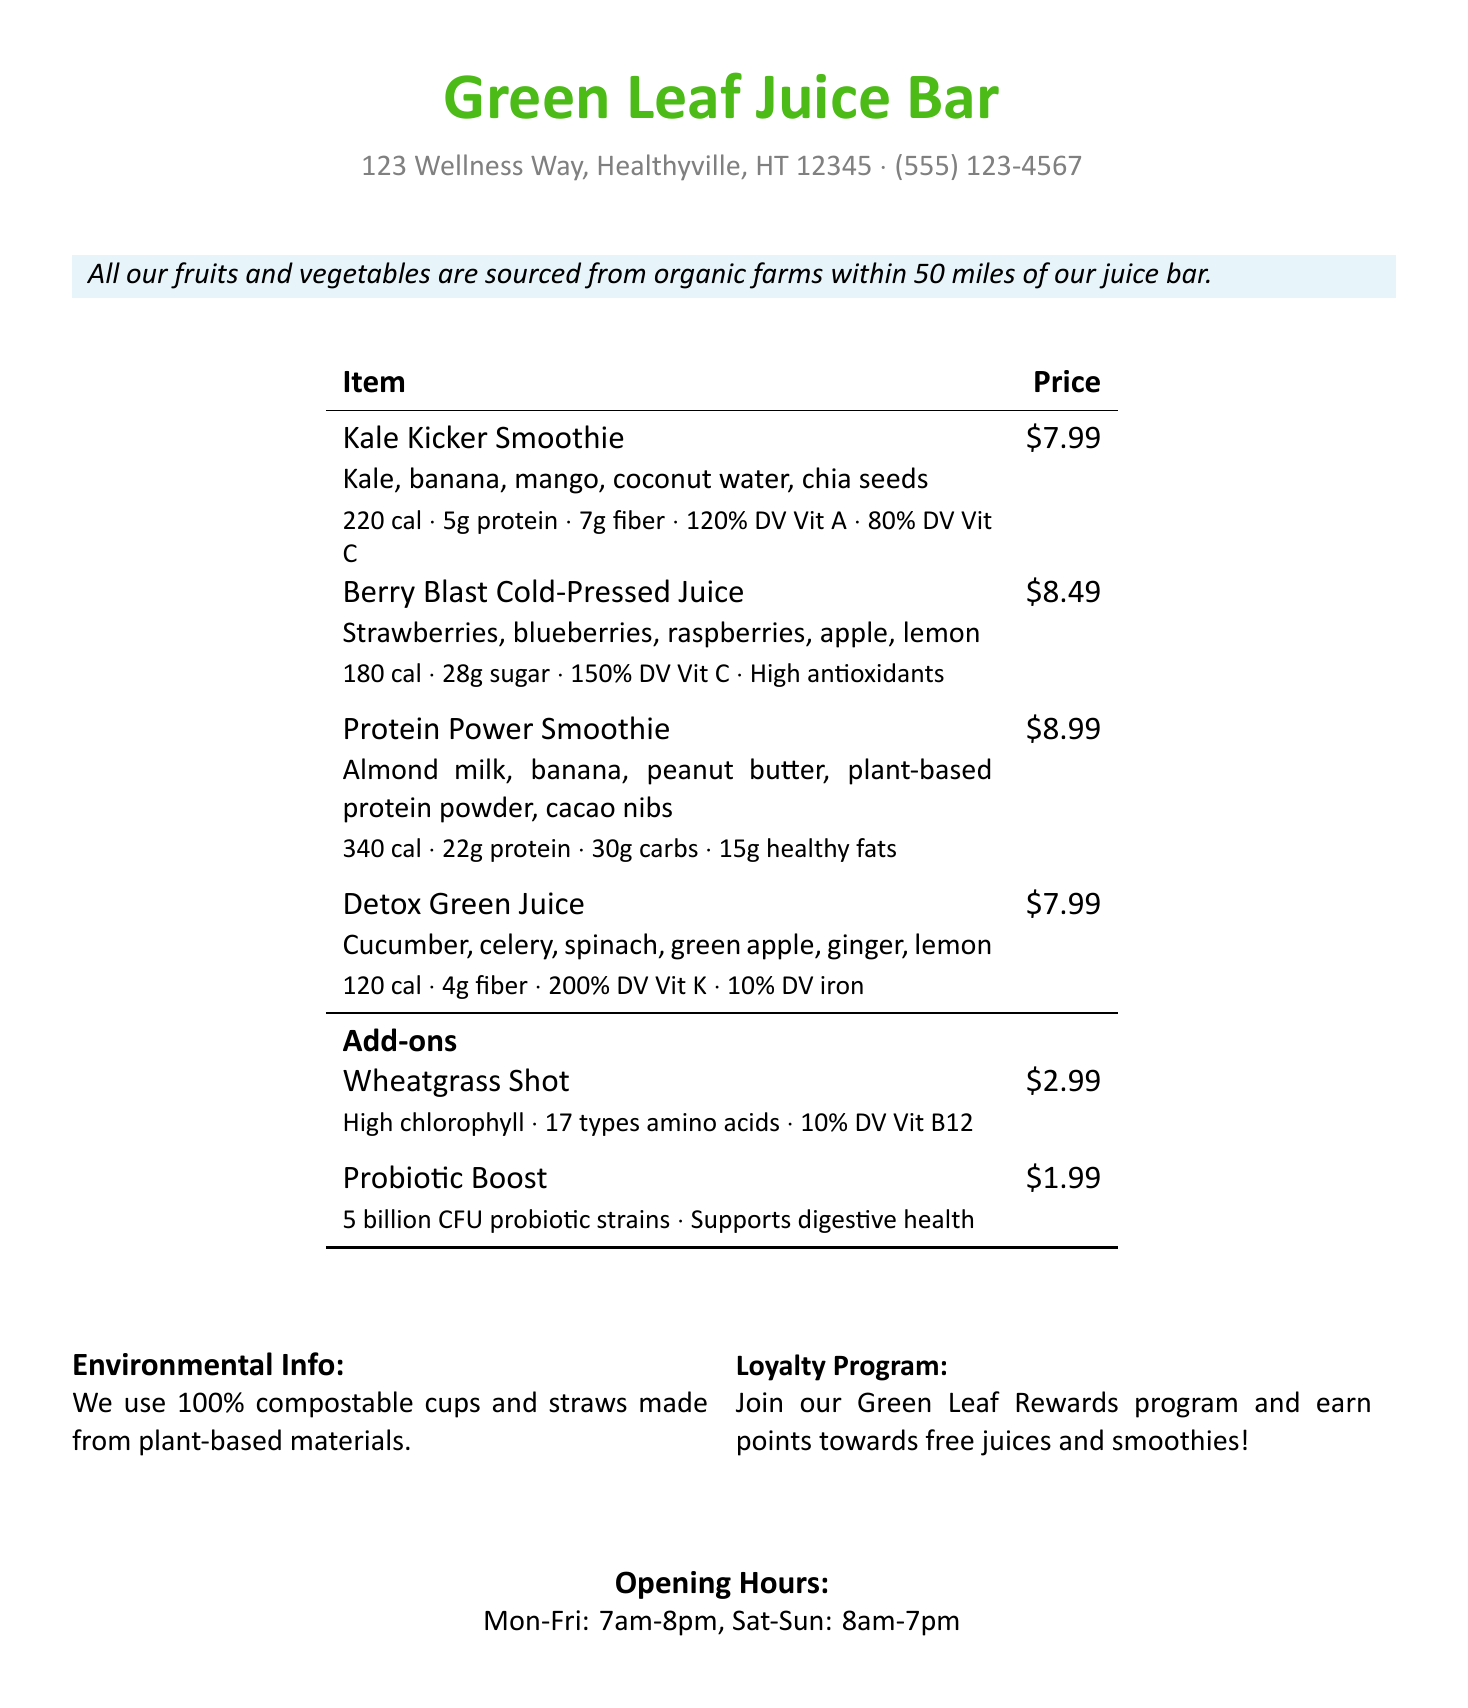What is the address of the juice bar? The address is listed in the document.
Answer: 123 Wellness Way, Healthyville, HT 12345 What is the price of the Protein Power Smoothie? The price is specifically mentioned next to the item on the receipt.
Answer: $8.99 How many grams of protein are in the Kale Kicker Smoothie? The protein content is provided in the nutritional information section for that smoothie.
Answer: 5g Which juice has the highest vitamin C content? By comparing the vitamin C information, Berry Blast has the highest value.
Answer: Berry Blast Cold-Pressed Juice What is included in the Detox Green Juice? The ingredients are listed for each beverage on the receipt.
Answer: Cucumber, celery, spinach, green apple, ginger, lemon What percentage of daily value of vitamin K does Detox Green Juice contain? The daily value percentage for vitamin K is provided in the nutritional info.
Answer: 200% DV What is a benefit of the Probiotic Boost? The beneficial aspect is detailed in the add-on section of the document.
Answer: Supports digestive health What are the opening hours on weekends? The opening hours are explicitly stated in the document for weekends.
Answer: 8am-7pm Is the juice bar's packaging environmentally friendly? The environmental information section confirms the packaging quality.
Answer: Yes 